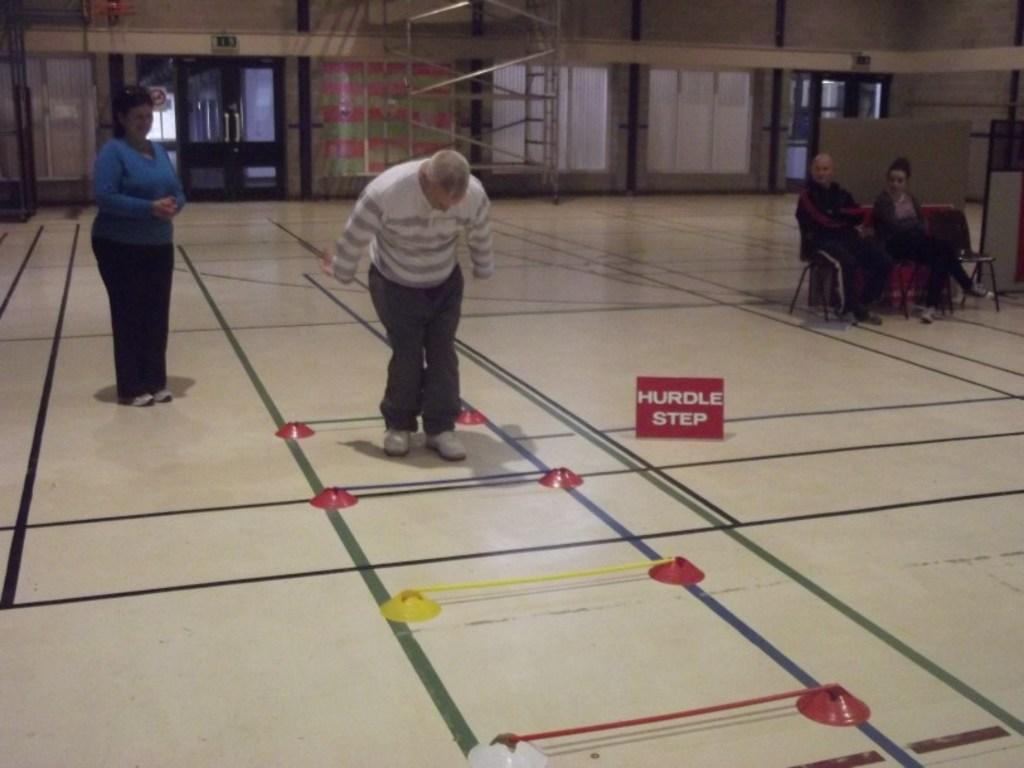What is the main subject of the image? The main subject of the image is a group of people. What are some of the people in the image doing? Some people are standing, while others are seated on chairs. What can be seen in the background of the image? There are metal rods and doors in the background of the image. What type of clam is being used as a chair by one of the people in the image? There are no clams present in the image; the chairs mentioned are regular chairs. 